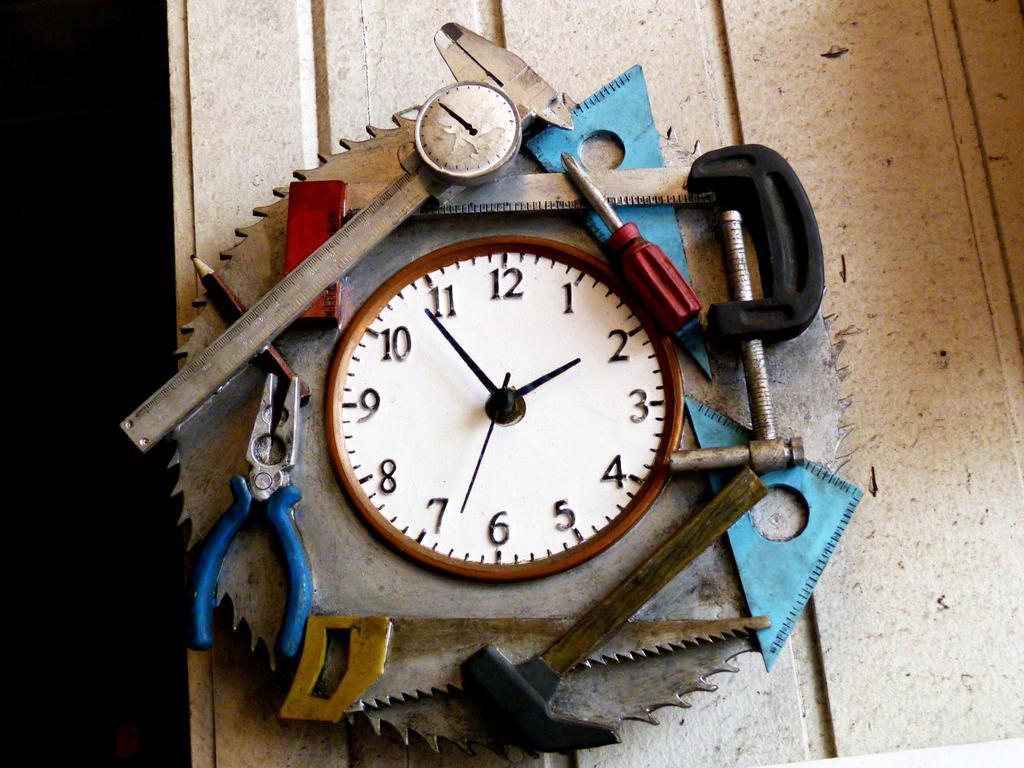Describe this image in one or two sentences. In this image I can see there is a table. On the table there is a machine, On that there is a clock, Around the clock there are some objects placed in it. 